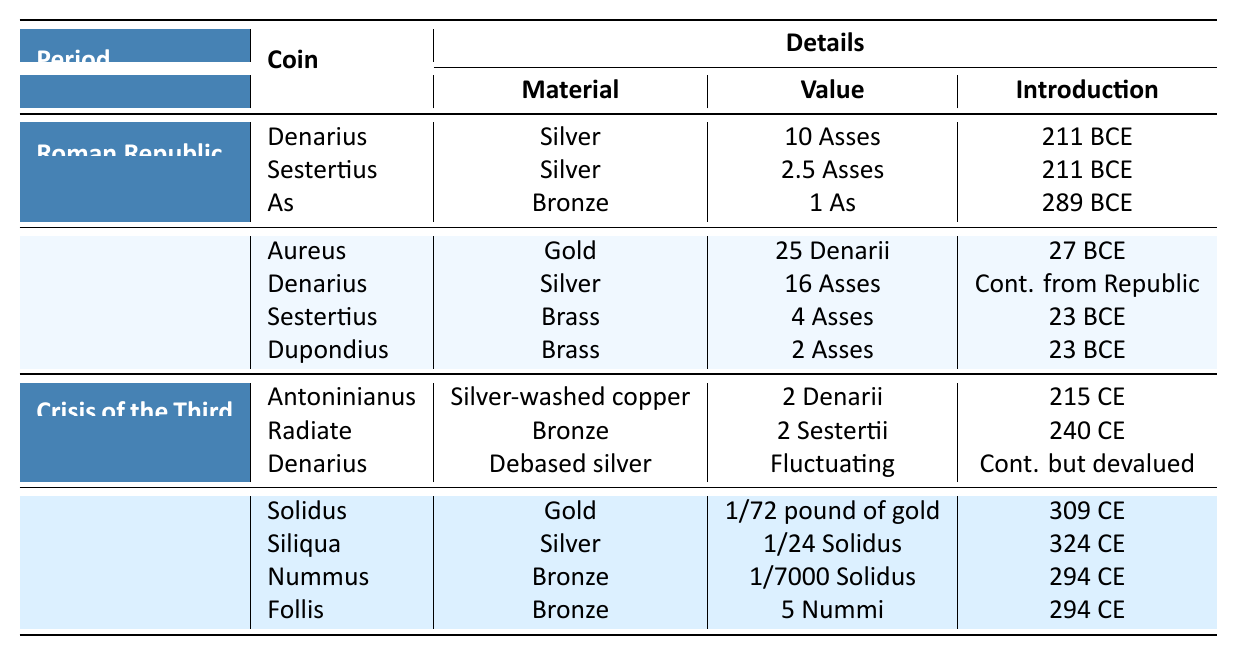What coin was introduced in 289 BCE? The table indicates that the coin "As" was introduced in 289 BCE under the Roman Republic.
Answer: As Which material was used for the Sestertius during the Early Empire? The table states that the material for the Sestertius during the Early Empire was Brass.
Answer: Brass How many Asses is the value of the Aureus? According to the table, the Aureus has a value of 25 Denarii, and it was introduced in the Early Empire. Denarii can be converted into Asses; since 1 Denarius equals 10 Asses, 25 Denarii equals 250 Asses (25 x 10).
Answer: 250 Asses Was the Denarius made of debased silver during the Crisis of the Third Century? The table confirms that the Denarius during this period was made of debased silver, as specified in the "Material" column for that denomination.
Answer: Yes What was the introduction year of the Solidus? The table shows that the Solidus was introduced in 309 CE during the Dominate period.
Answer: 309 CE Which coin type had a fluctuating value during the Crisis of the Third Century? The table indicates that the Denarius from the Crisis of the Third Century had a fluctuating value, as mentioned in the "Value" column for this coin.
Answer: Denarius How many different types of coins are listed for the Dominate period? The table lists four different types of coins for the Dominate period: Solidus, Siliqua, Nummus, and Follis. This can be counted directly from the entry for that period.
Answer: 4 What is the total number of coins introduced in the Early Empire? The table specifies four coins introduced during the Early Empire: Aureus, Denarius, Sestertius, and Dupondius. Therefore, we sum the types provided under that period: 4.
Answer: 4 Is it true that the Denarius and Sestertius under the Roman Republic were made of the same material? Both the Denarius and Sestertius are listed as being made of silver in the Roman Republic period, making this statement true.
Answer: Yes What is the difference in the total value of the coins in the Roman Republic compared to the Dominate? Summing the values shown, the total for the Roman Republic is (10 Asses + 2.5 Asses + 1 As = 13.5 Asses) and for the Dominate (1/72 pound gold, 1/24 Solidus, 1/7000 Solidus, and 5 Nummi have no comparable value provided). Therefore, the Roman Republic has a clear value while the Dominate's value cannot be quantified here, technically making it a difference without a direct comparison.
Answer: Not computable Which period introduced the coin called Follis? The table shows that the Follis was introduced in the Dominate period (294 CE).
Answer: Dominate 